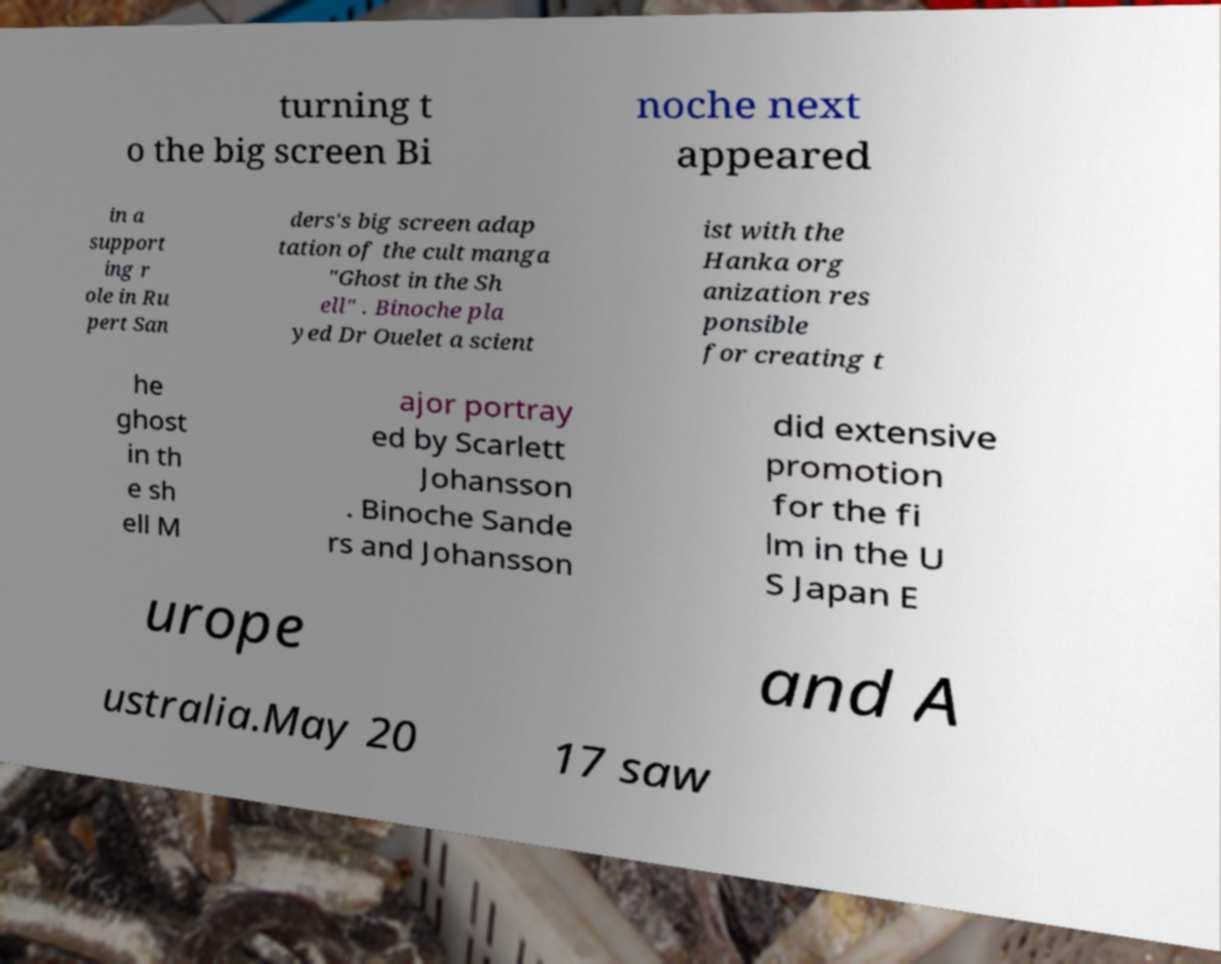Please read and relay the text visible in this image. What does it say? turning t o the big screen Bi noche next appeared in a support ing r ole in Ru pert San ders's big screen adap tation of the cult manga "Ghost in the Sh ell" . Binoche pla yed Dr Ouelet a scient ist with the Hanka org anization res ponsible for creating t he ghost in th e sh ell M ajor portray ed by Scarlett Johansson . Binoche Sande rs and Johansson did extensive promotion for the fi lm in the U S Japan E urope and A ustralia.May 20 17 saw 